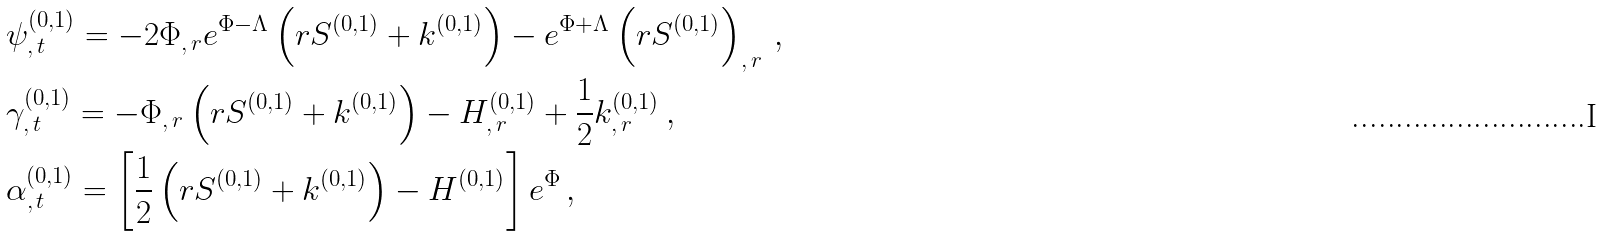Convert formula to latex. <formula><loc_0><loc_0><loc_500><loc_500>& \psi _ { , \, t } ^ { ( 0 , 1 ) } = - 2 \Phi _ { , \, r } e ^ { \Phi - \Lambda } \left ( r S ^ { ( 0 , 1 ) } + k ^ { ( 0 , 1 ) } \right ) - e ^ { \Phi + \Lambda } \left ( r S ^ { ( 0 , 1 ) } \right ) _ { , \, r } \, , \\ & \gamma _ { , \, t } ^ { ( 0 , 1 ) } = - \Phi _ { , \, r } \left ( r S ^ { ( 0 , 1 ) } + k ^ { ( 0 , 1 ) } \right ) - H _ { , \, r } ^ { ( 0 , 1 ) } + \frac { 1 } { 2 } k _ { , \, r } ^ { ( 0 , 1 ) } \, , \\ & \alpha _ { , \, t } ^ { ( 0 , 1 ) } = \left [ \frac { 1 } { 2 } \left ( r S ^ { ( 0 , 1 ) } + k ^ { ( 0 , 1 ) } \right ) - H ^ { ( 0 , 1 ) } \right ] e ^ { \Phi } \, ,</formula> 